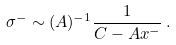Convert formula to latex. <formula><loc_0><loc_0><loc_500><loc_500>\sigma ^ { - } \sim ( A ) ^ { - 1 } \frac { 1 } { C - A x ^ { - } } \, .</formula> 